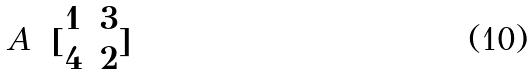Convert formula to latex. <formula><loc_0><loc_0><loc_500><loc_500>A = [ \begin{matrix} 1 & 3 \\ 4 & 2 \end{matrix} ]</formula> 